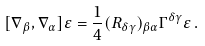Convert formula to latex. <formula><loc_0><loc_0><loc_500><loc_500>[ \nabla _ { \beta } , \nabla _ { \alpha } ] \varepsilon = \frac { 1 } { 4 } ( R _ { \delta \gamma } ) _ { \beta \alpha } \Gamma ^ { \delta \gamma } \varepsilon \, .</formula> 